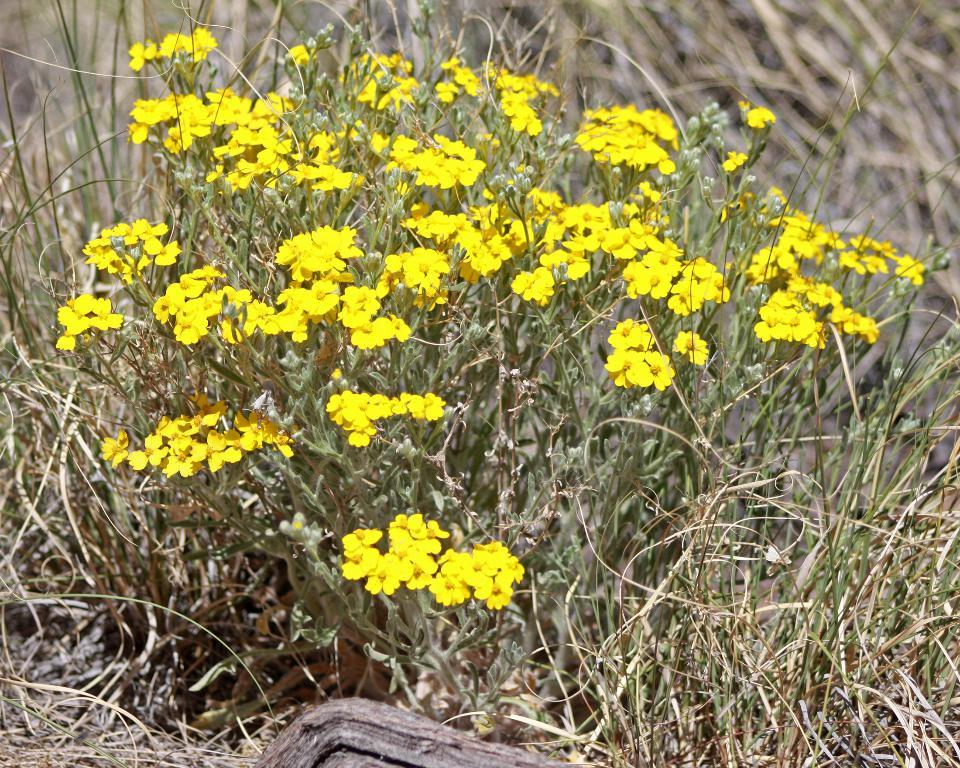What type of flowers can be seen in the image? There are yellow flowers in the image. What is on the ground in the image? There is grass on the ground in the image. Can you describe the background of the image? The background of the image is blurry. Where is the beam located in the image? There is no beam present in the image. Can you spot a frog hopping among the yellow flowers in the image? There is no frog present in the image. 